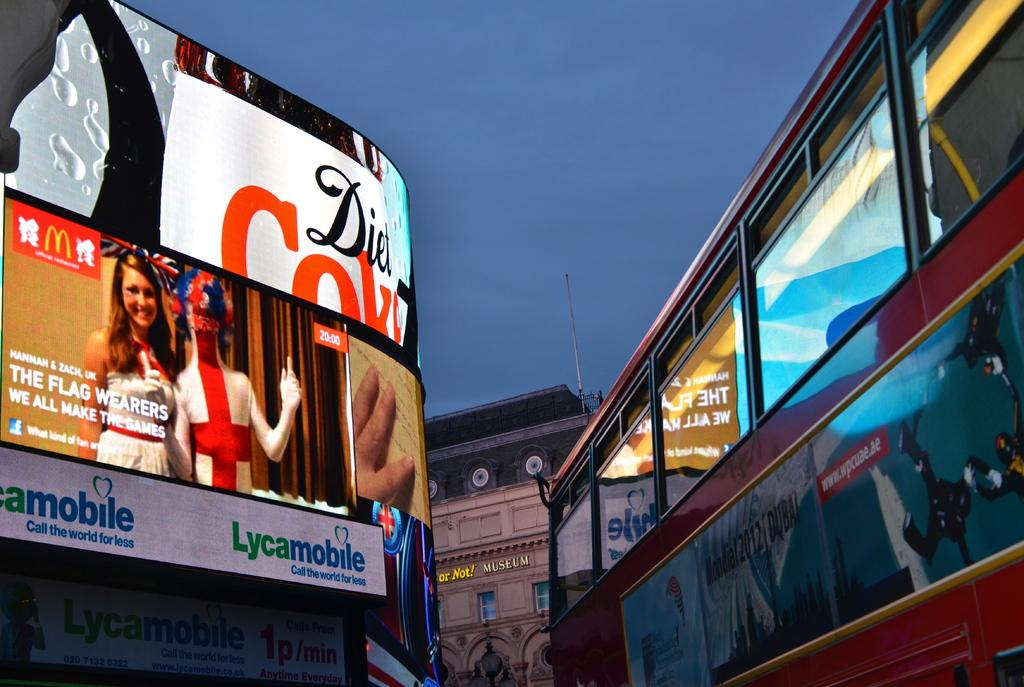<image>
Share a concise interpretation of the image provided. a lighted up building that says 'diet coke' on it 